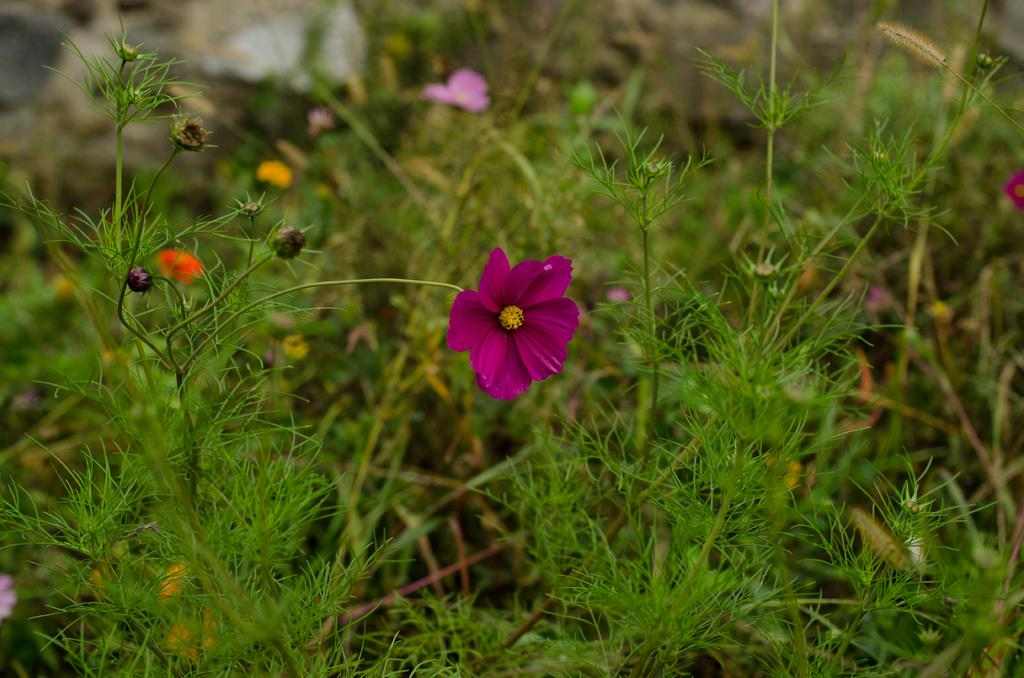What type of living organisms can be seen in the image? Plants and flowers are visible in the image. Can you describe the flowers in the image? The flowers in the image are not specified, but they are present alongside the plants. What type of haircut is the plant getting in the image? There is no haircut being performed on the plant in the image, as plants do not have hair. 